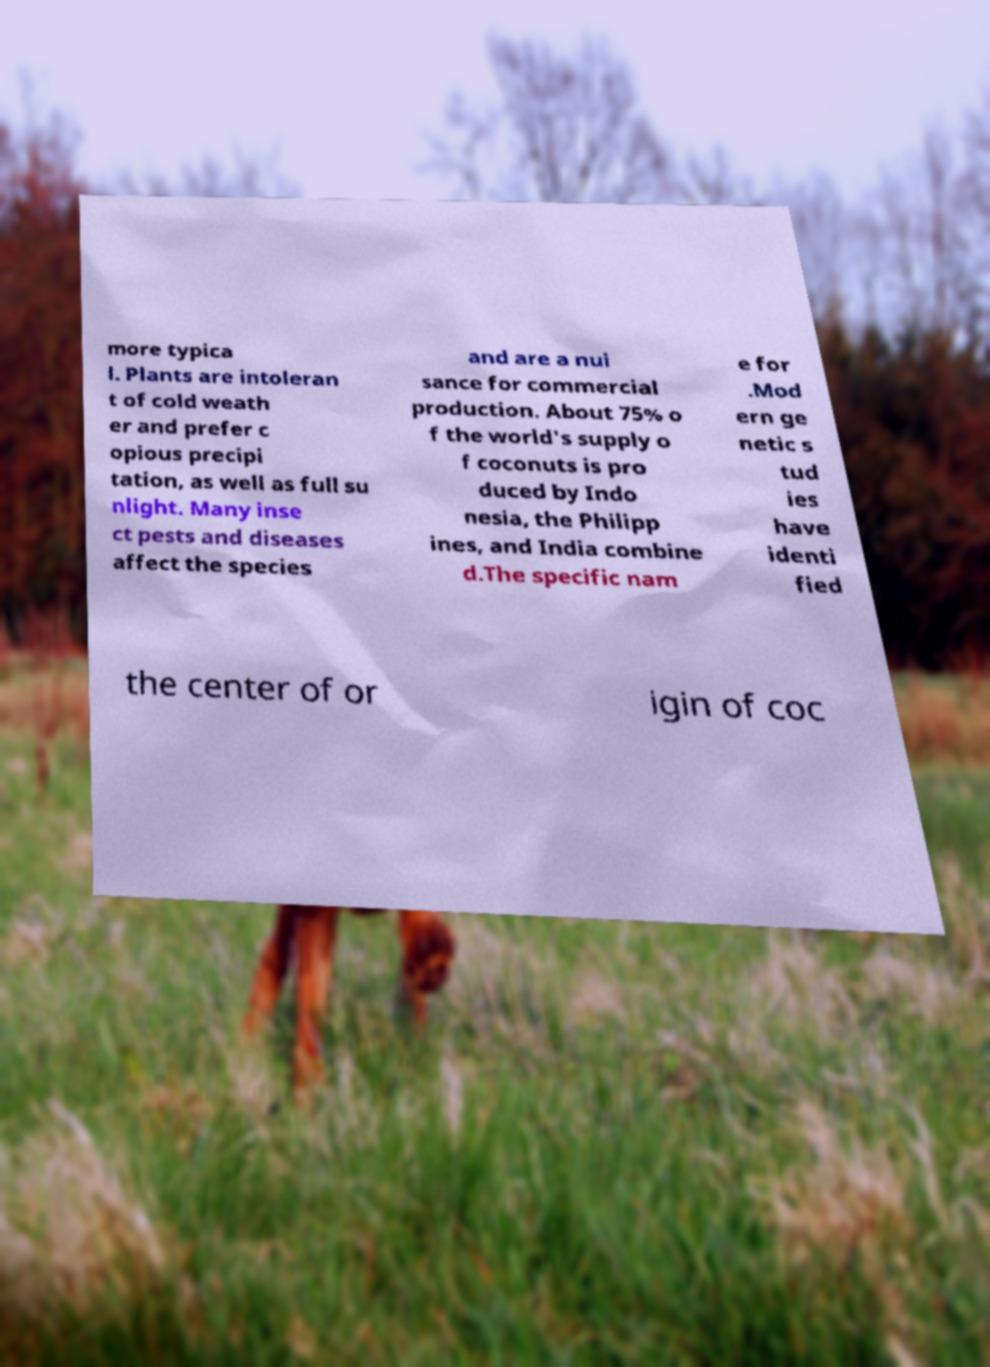Can you read and provide the text displayed in the image?This photo seems to have some interesting text. Can you extract and type it out for me? more typica l. Plants are intoleran t of cold weath er and prefer c opious precipi tation, as well as full su nlight. Many inse ct pests and diseases affect the species and are a nui sance for commercial production. About 75% o f the world's supply o f coconuts is pro duced by Indo nesia, the Philipp ines, and India combine d.The specific nam e for .Mod ern ge netic s tud ies have identi fied the center of or igin of coc 